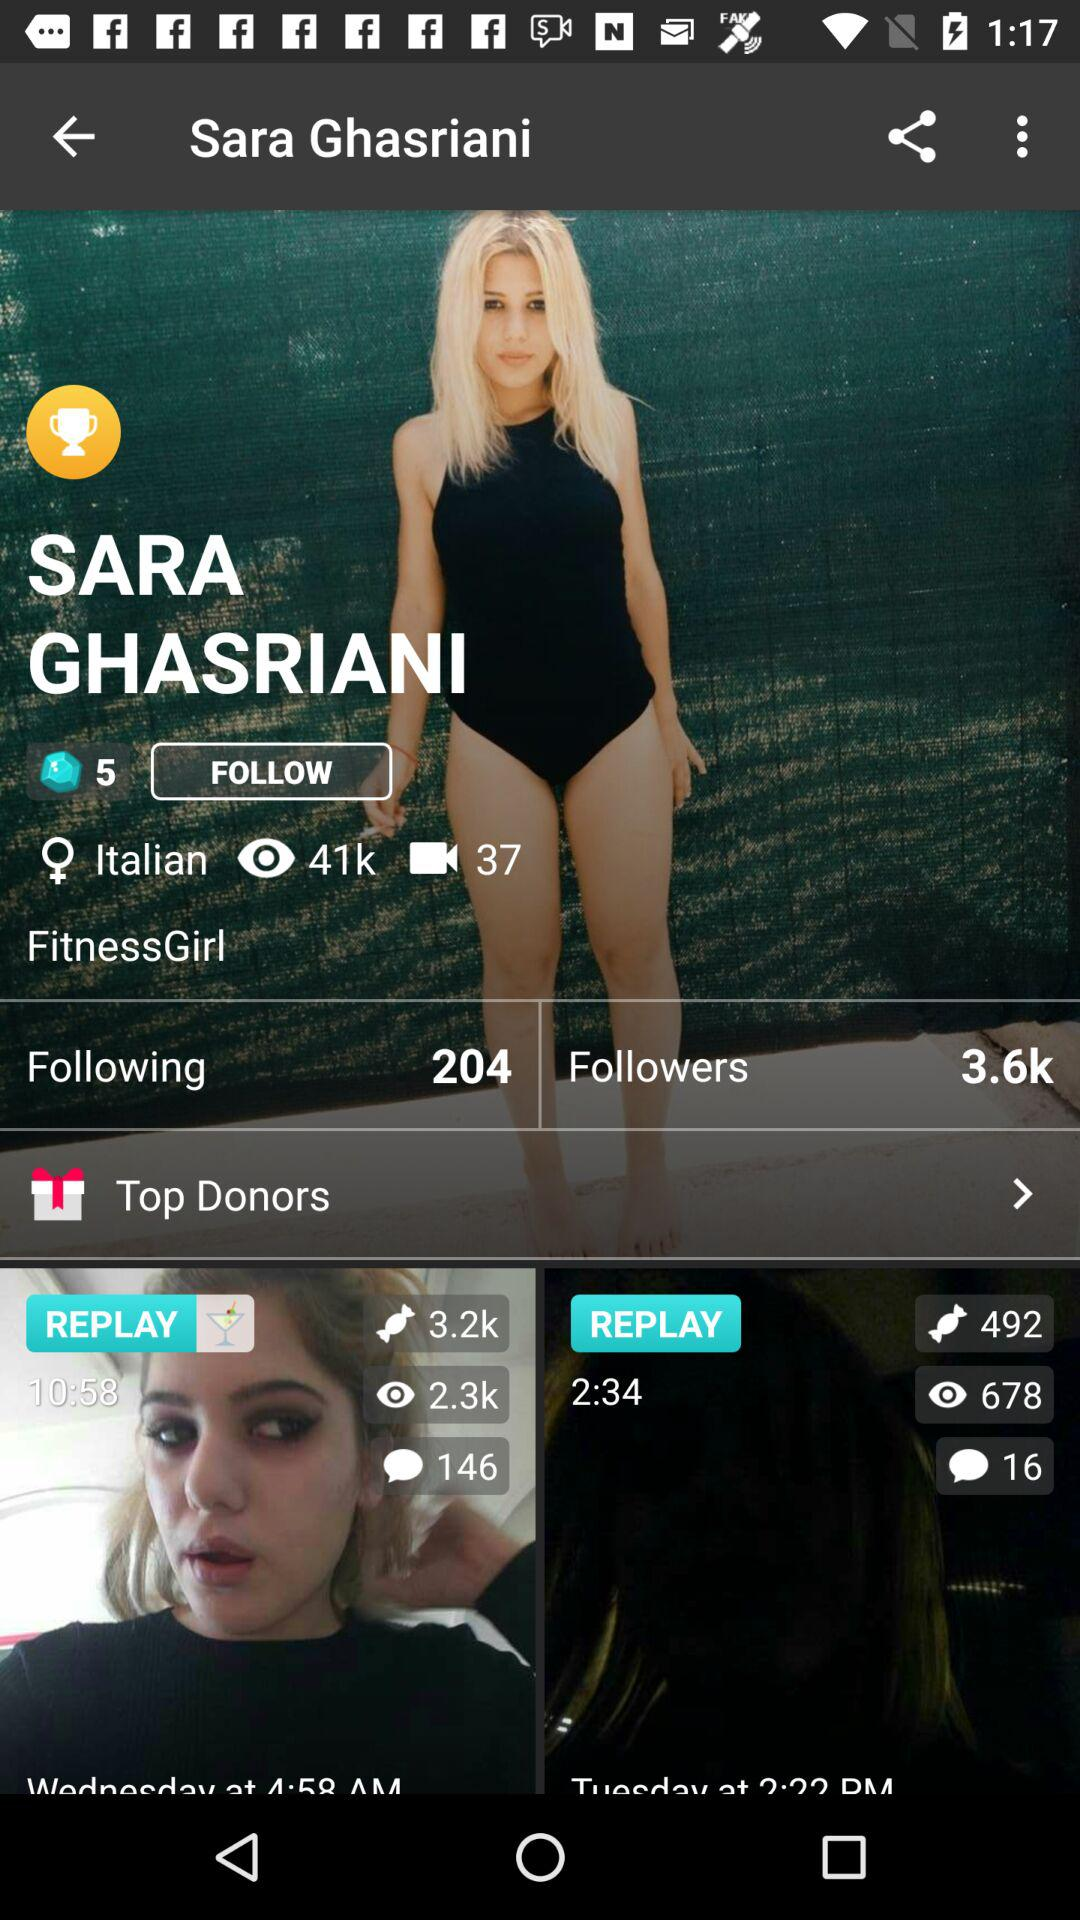How many people follow Sara Ghasriani? The people who follow Sara Ghasriani are 3.6k. 